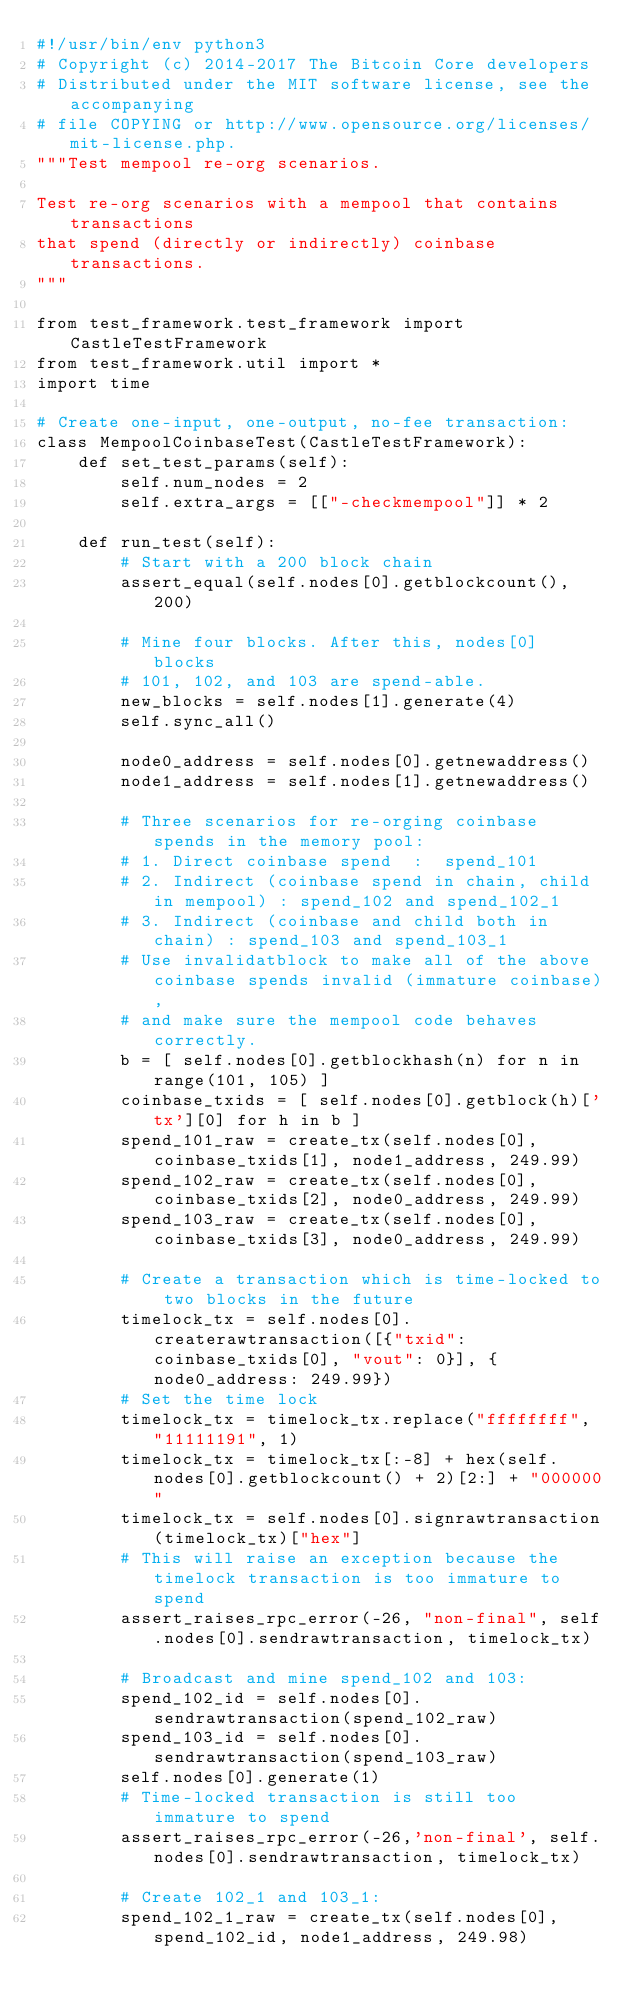<code> <loc_0><loc_0><loc_500><loc_500><_Python_>#!/usr/bin/env python3
# Copyright (c) 2014-2017 The Bitcoin Core developers
# Distributed under the MIT software license, see the accompanying
# file COPYING or http://www.opensource.org/licenses/mit-license.php.
"""Test mempool re-org scenarios.

Test re-org scenarios with a mempool that contains transactions
that spend (directly or indirectly) coinbase transactions.
"""

from test_framework.test_framework import CastleTestFramework
from test_framework.util import *
import time

# Create one-input, one-output, no-fee transaction:
class MempoolCoinbaseTest(CastleTestFramework):
    def set_test_params(self):
        self.num_nodes = 2
        self.extra_args = [["-checkmempool"]] * 2

    def run_test(self):
        # Start with a 200 block chain
        assert_equal(self.nodes[0].getblockcount(), 200)

        # Mine four blocks. After this, nodes[0] blocks
        # 101, 102, and 103 are spend-able.
        new_blocks = self.nodes[1].generate(4)
        self.sync_all()

        node0_address = self.nodes[0].getnewaddress()
        node1_address = self.nodes[1].getnewaddress()

        # Three scenarios for re-orging coinbase spends in the memory pool:
        # 1. Direct coinbase spend  :  spend_101
        # 2. Indirect (coinbase spend in chain, child in mempool) : spend_102 and spend_102_1
        # 3. Indirect (coinbase and child both in chain) : spend_103 and spend_103_1
        # Use invalidatblock to make all of the above coinbase spends invalid (immature coinbase),
        # and make sure the mempool code behaves correctly.
        b = [ self.nodes[0].getblockhash(n) for n in range(101, 105) ]
        coinbase_txids = [ self.nodes[0].getblock(h)['tx'][0] for h in b ]
        spend_101_raw = create_tx(self.nodes[0], coinbase_txids[1], node1_address, 249.99)
        spend_102_raw = create_tx(self.nodes[0], coinbase_txids[2], node0_address, 249.99)
        spend_103_raw = create_tx(self.nodes[0], coinbase_txids[3], node0_address, 249.99)

        # Create a transaction which is time-locked to two blocks in the future
        timelock_tx = self.nodes[0].createrawtransaction([{"txid": coinbase_txids[0], "vout": 0}], {node0_address: 249.99})
        # Set the time lock
        timelock_tx = timelock_tx.replace("ffffffff", "11111191", 1)
        timelock_tx = timelock_tx[:-8] + hex(self.nodes[0].getblockcount() + 2)[2:] + "000000"
        timelock_tx = self.nodes[0].signrawtransaction(timelock_tx)["hex"]
        # This will raise an exception because the timelock transaction is too immature to spend
        assert_raises_rpc_error(-26, "non-final", self.nodes[0].sendrawtransaction, timelock_tx)

        # Broadcast and mine spend_102 and 103:
        spend_102_id = self.nodes[0].sendrawtransaction(spend_102_raw)
        spend_103_id = self.nodes[0].sendrawtransaction(spend_103_raw)
        self.nodes[0].generate(1)
        # Time-locked transaction is still too immature to spend
        assert_raises_rpc_error(-26,'non-final', self.nodes[0].sendrawtransaction, timelock_tx)

        # Create 102_1 and 103_1:
        spend_102_1_raw = create_tx(self.nodes[0], spend_102_id, node1_address, 249.98)</code> 